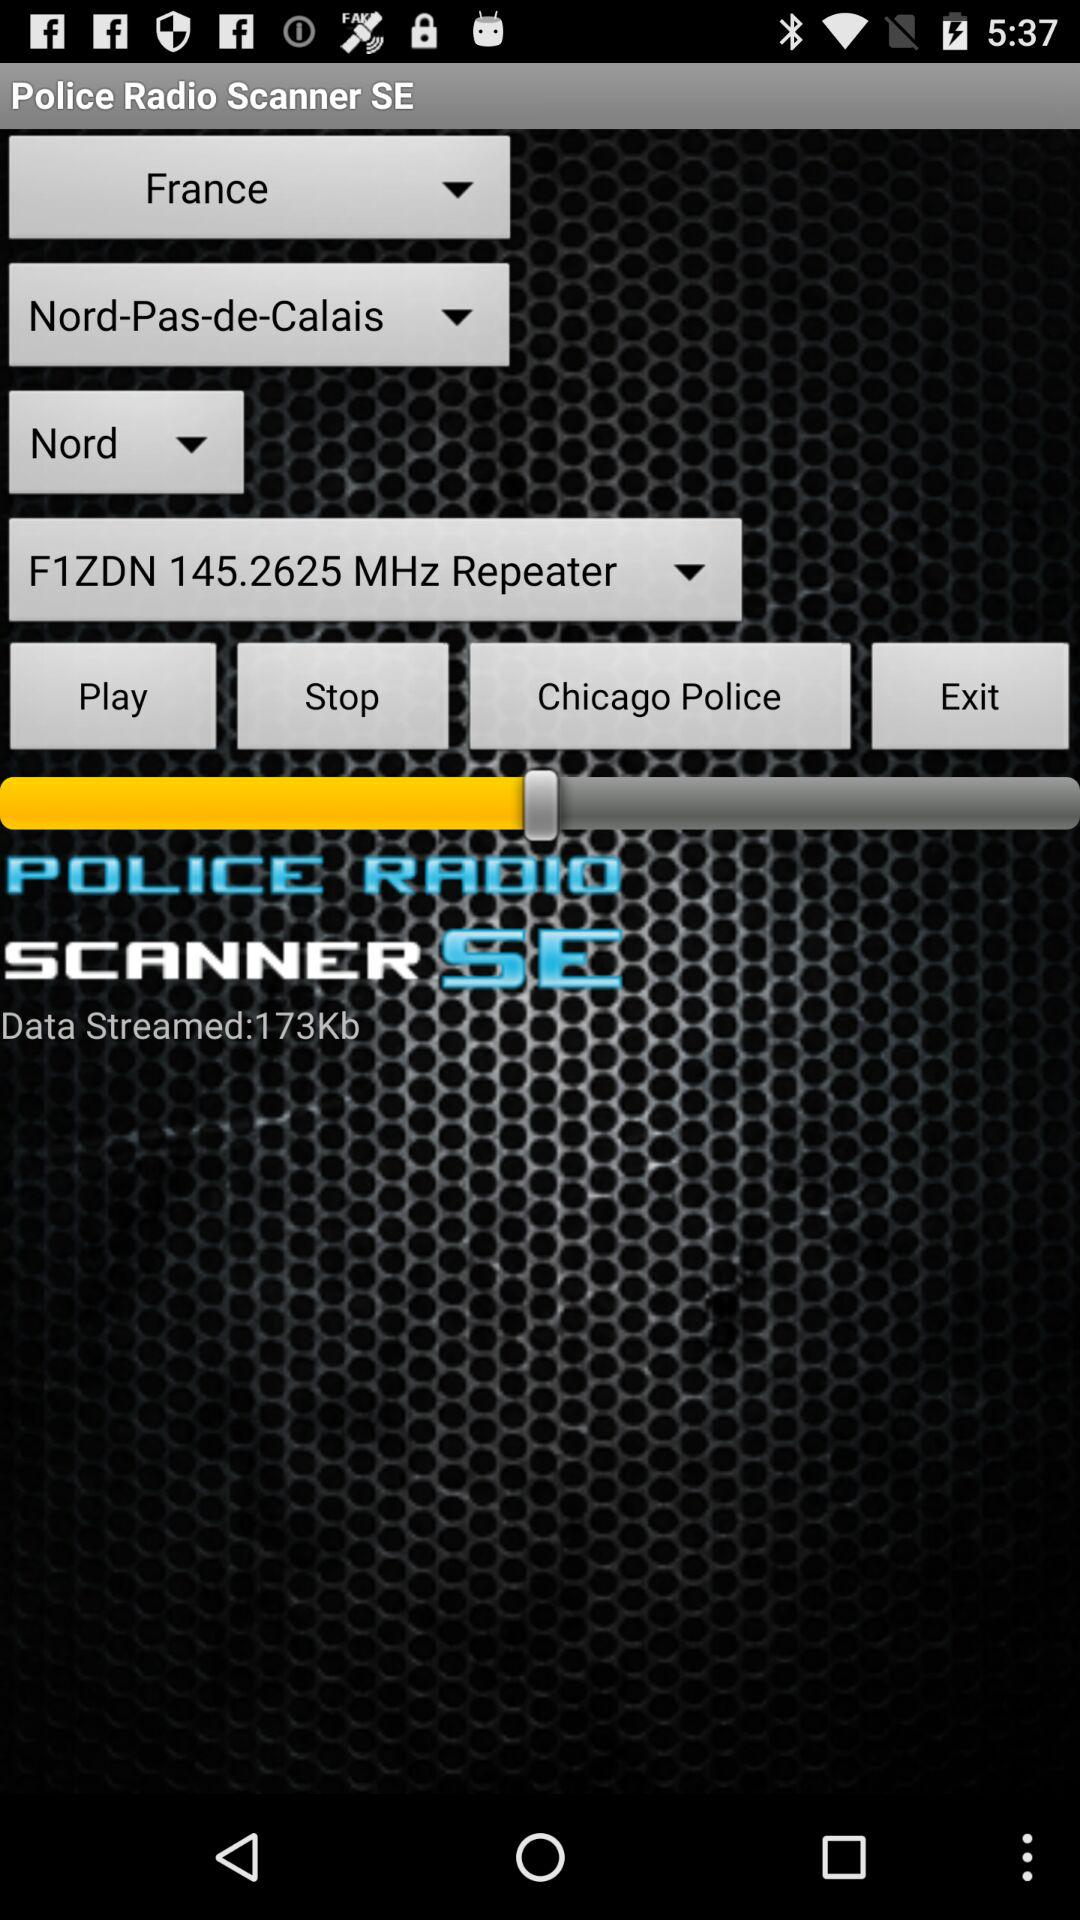What is the application name? The application name is "Police Radio Scanner SE". 